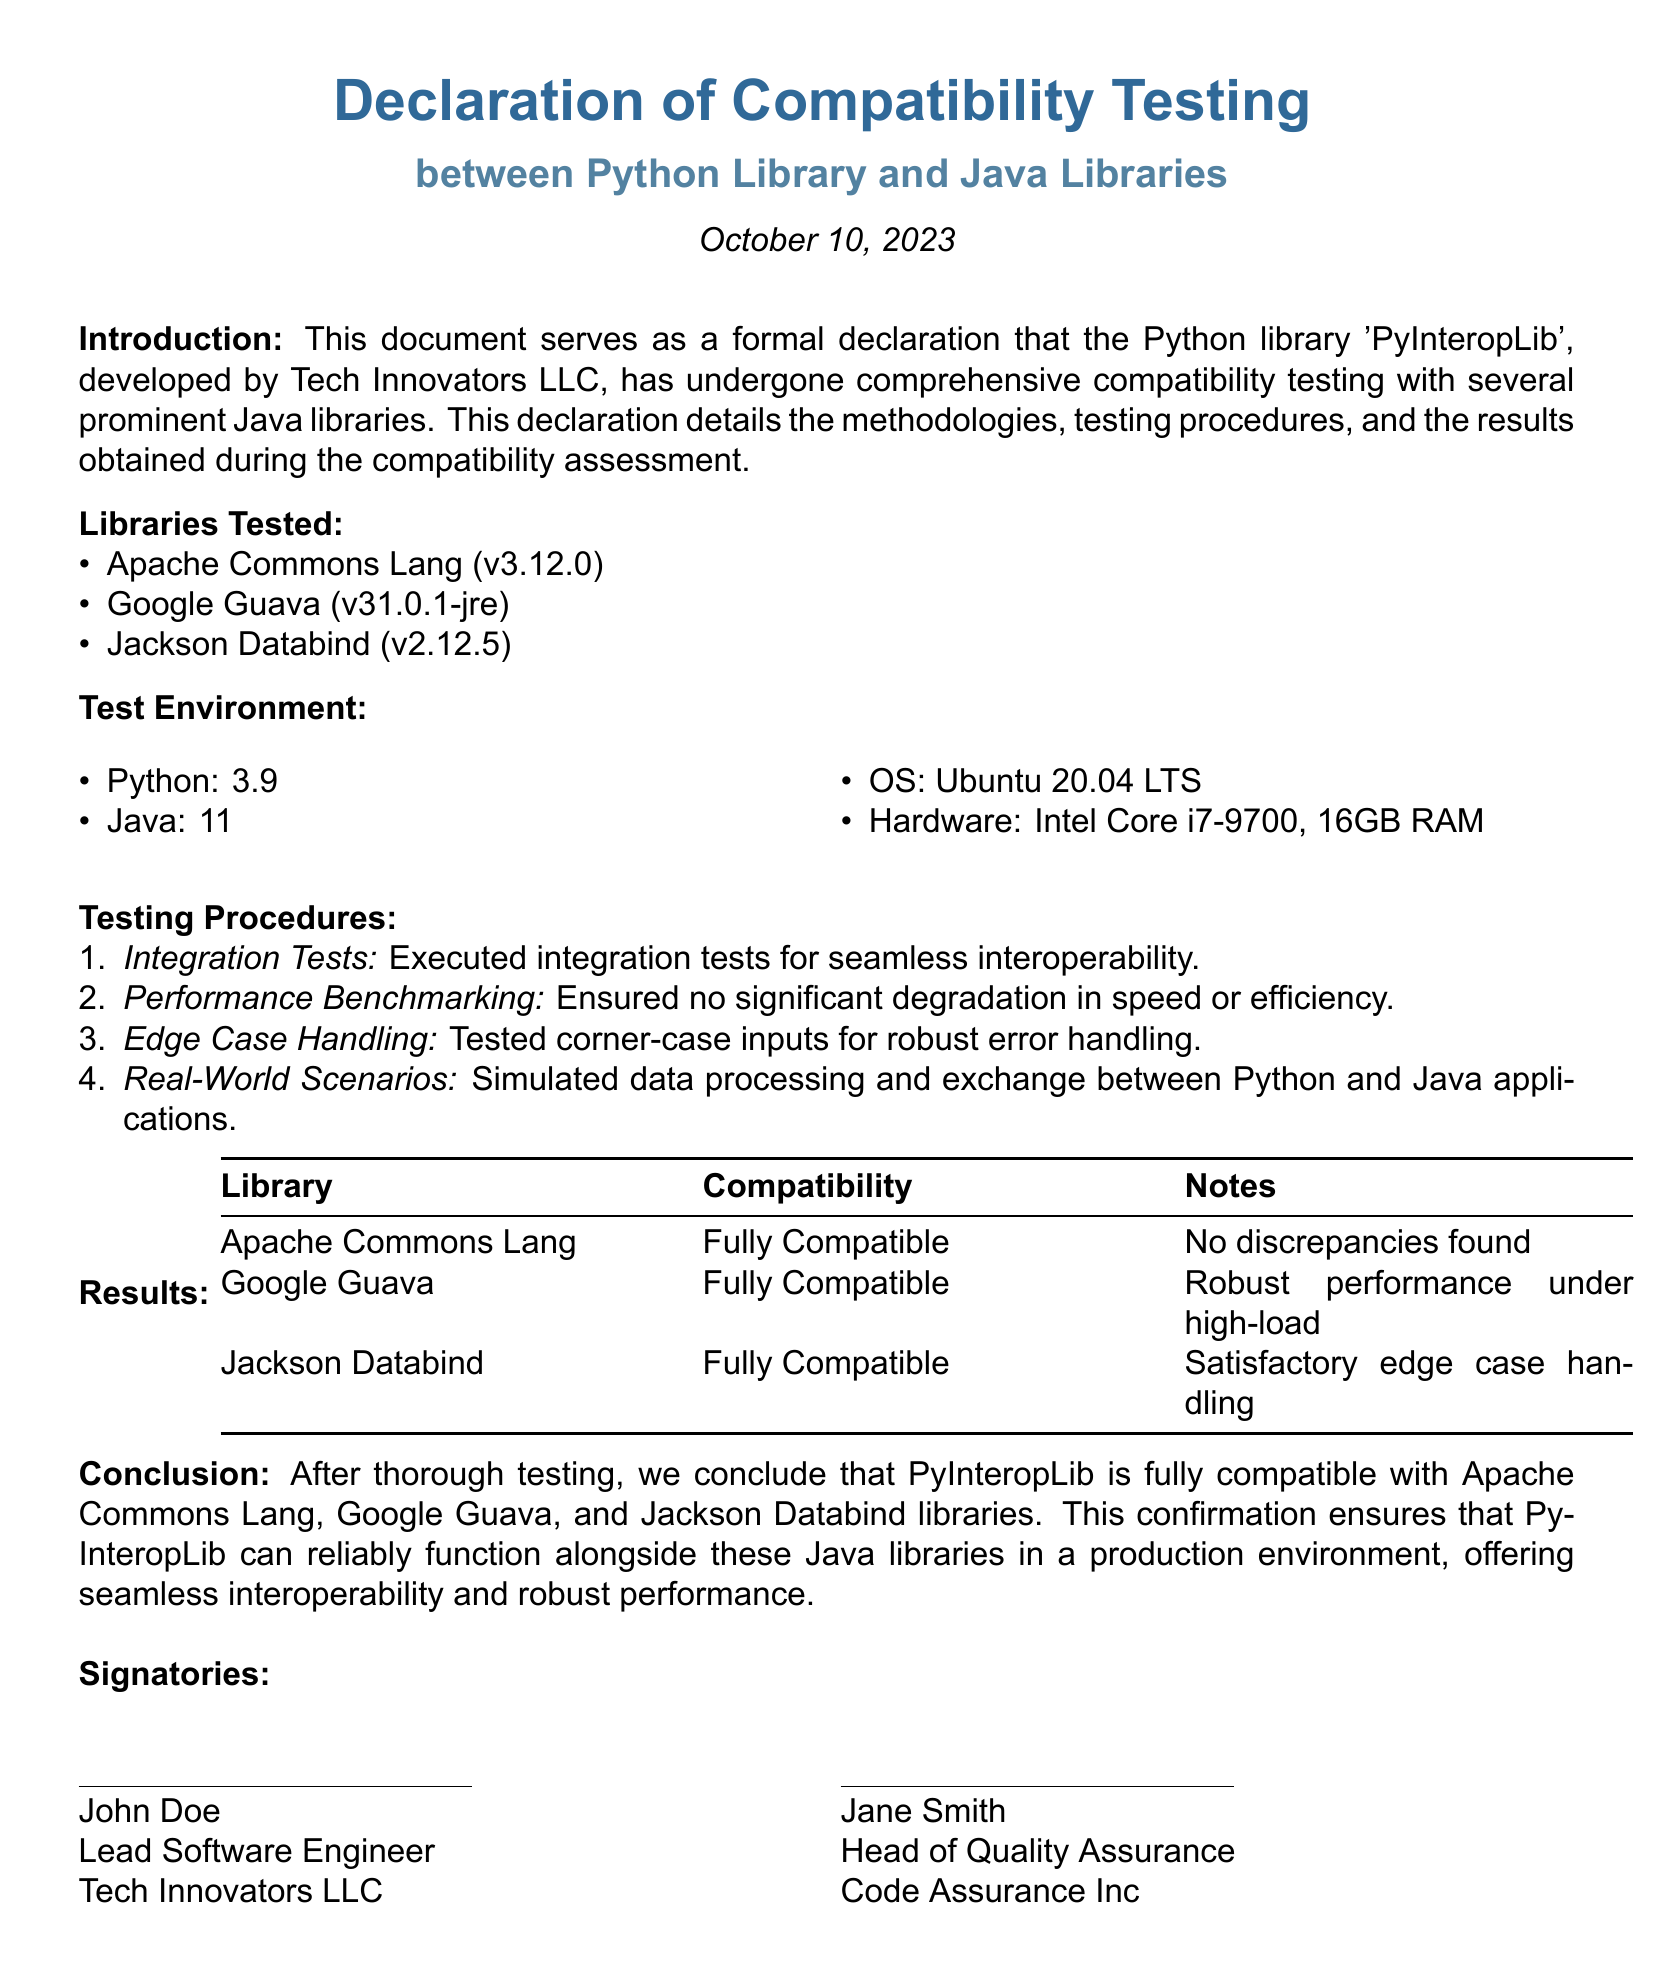What is the name of the Python library? The document mentions "PyInteropLib" as the name of the Python library that has undergone compatibility testing.
Answer: PyInteropLib Who developed the Python library? According to the introduction, the Python library was developed by Tech Innovators LLC.
Answer: Tech Innovators LLC What date was the declaration signed? The document indicates that the declaration was made on October 10, 2023.
Answer: October 10, 2023 Which Java library is noted for robust performance under high-load? In the results section, Google Guava is specifically noted for its robust performance under high-load conditions.
Answer: Google Guava How many libraries were tested for compatibility? The document lists three Java libraries that were subjected to compatibility testing.
Answer: Three What is the operating system used for testing? The test environment section of the document states that Ubuntu 20.04 LTS was used as the operating system.
Answer: Ubuntu 20.04 LTS Who is the Head of Quality Assurance at Code Assurance Inc? The document lists Jane Smith as the Head of Quality Assurance.
Answer: Jane Smith What type of tests were executed to ensure seamless interoperability? The document specifies that "Integration Tests" were executed to ensure seamless interoperability.
Answer: Integration Tests 